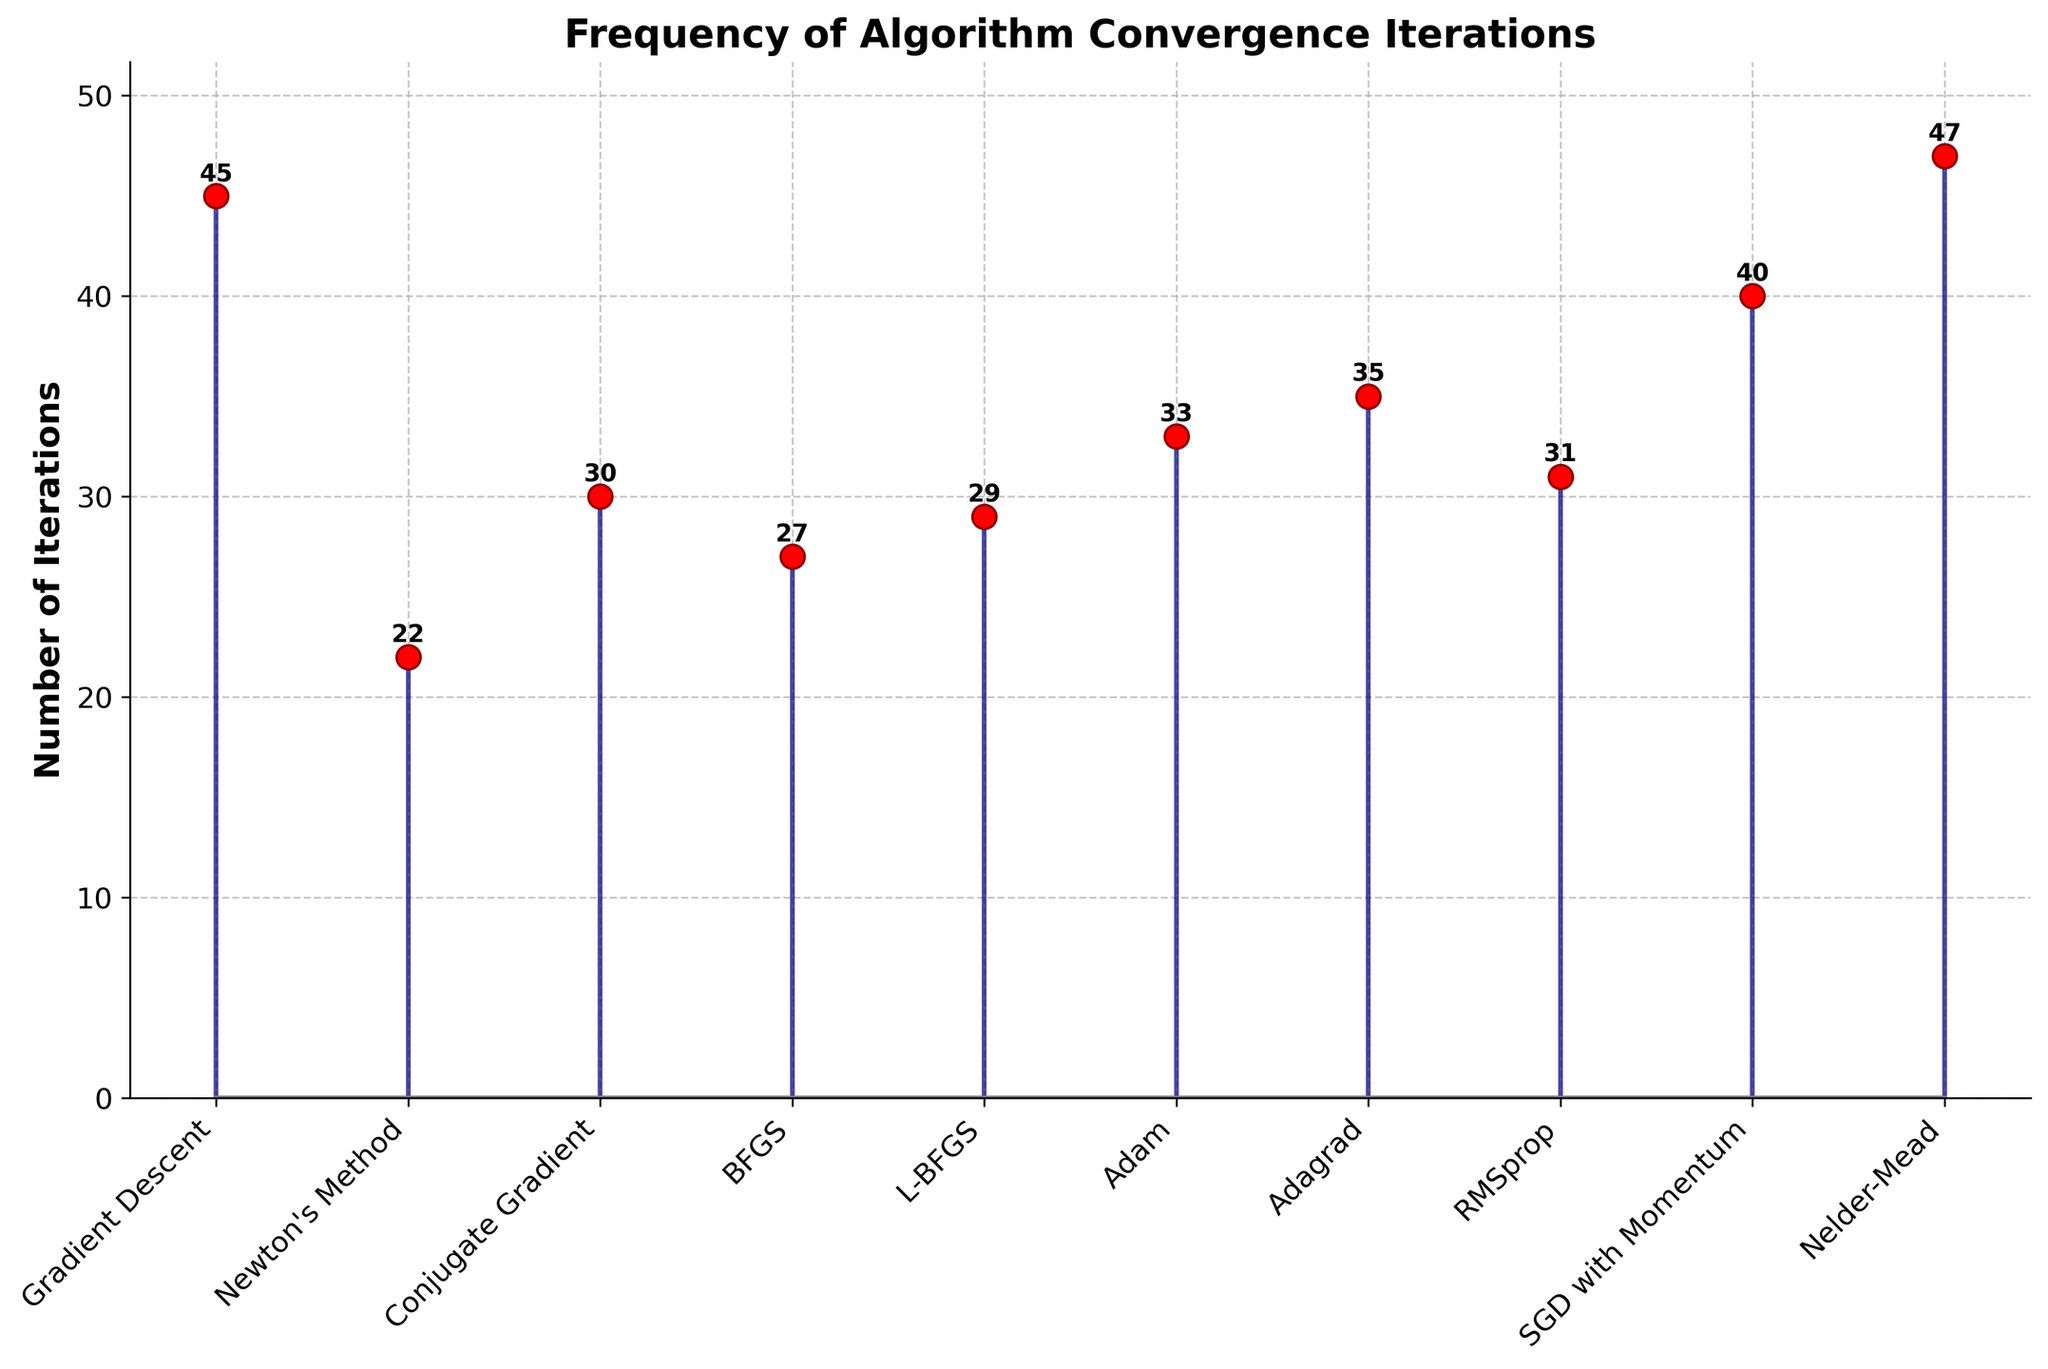What is the title of the plot? The title of the plot is prominently displayed at the top and typically summarizes the overall theme or subject of the visualization.
Answer: Frequency of Algorithm Convergence Iterations How many algorithms are plotted? Each data point in the plot represents a different algorithm, and they are listed along the x-axis. By counting these data points, we can determine the number of algorithms.
Answer: 10 Which algorithm took the maximum number of iterations to converge? By observing the heights of the stems and the numbers annotated above each stem, we can identify the algorithm with the highest value. The algorithm with the highest stem has the maximum iterations.
Answer: Nelder-Mead What is the number of iterations for Newton's Method? The number of iterations for Newton's Method is directly annotated above its corresponding stem.
Answer: 22 Which two algorithms' convergence iterations are closest to each other? By comparing the numerical values and heights of the stems, we can identify the two algorithms whose iterative values have the smallest difference.
Answer: BFGS and L-BFGS What is the average number of iterations for Gradient Descent, Adam, and Adagrad? To find the average, sum the iterations for each algorithm and then divide by the number of algorithms: (45 for Gradient Descent + 33 for Adam + 35 for Adagrad) / 3.
Answer: 37.67 What is the range of iterations in the plot? The range is calculated by finding the difference between the maximum and minimum values of iterations from the data. The maximum is 47 (Nelder-Mead) and the minimum is 22 (Newton's Method), so the range is 47 - 22.
Answer: 25 Which algorithm shows a comparable number of iterations to SGD with Momentum? By visually comparing the height of the stem for SGD with Momentum (which is 40) to other stems, we can identify any algorithms with similar iterations.
Answer: Gradient Descent How are the stems visually differentiated in the plot? The stems are differentiated using various visual markers and styles, such as line color, marker size, and shape. The question requires observing these visual distinctions.
Answer: Dark blue lines with red circle markers 